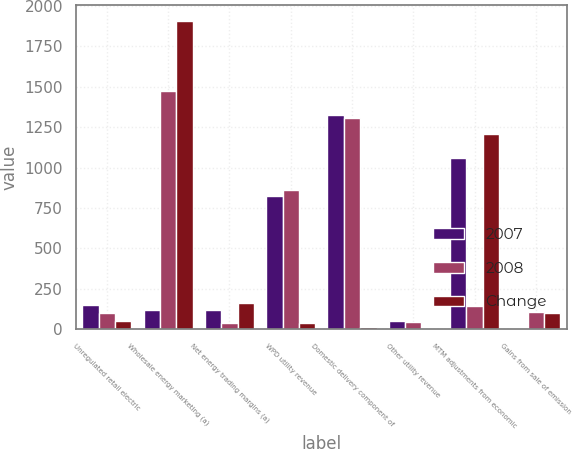Convert chart to OTSL. <chart><loc_0><loc_0><loc_500><loc_500><stacked_bar_chart><ecel><fcel>Unregulated retail electric<fcel>Wholesale energy marketing (a)<fcel>Net energy trading margins (a)<fcel>WPD utility revenue<fcel>Domestic delivery component of<fcel>Other utility revenue<fcel>MTM adjustments from economic<fcel>Gains from sale of emission<nl><fcel>2007<fcel>151<fcel>121<fcel>121<fcel>824<fcel>1325<fcel>52<fcel>1061<fcel>6<nl><fcel>2008<fcel>102<fcel>1472<fcel>41<fcel>863<fcel>1308<fcel>48<fcel>145<fcel>109<nl><fcel>Change<fcel>49<fcel>1909<fcel>162<fcel>39<fcel>17<fcel>4<fcel>1206<fcel>103<nl></chart> 